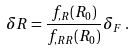Convert formula to latex. <formula><loc_0><loc_0><loc_500><loc_500>\delta R = \frac { f _ { , R } ( R _ { 0 } ) } { f _ { , R R } ( R _ { 0 } ) } \delta _ { F } \, .</formula> 